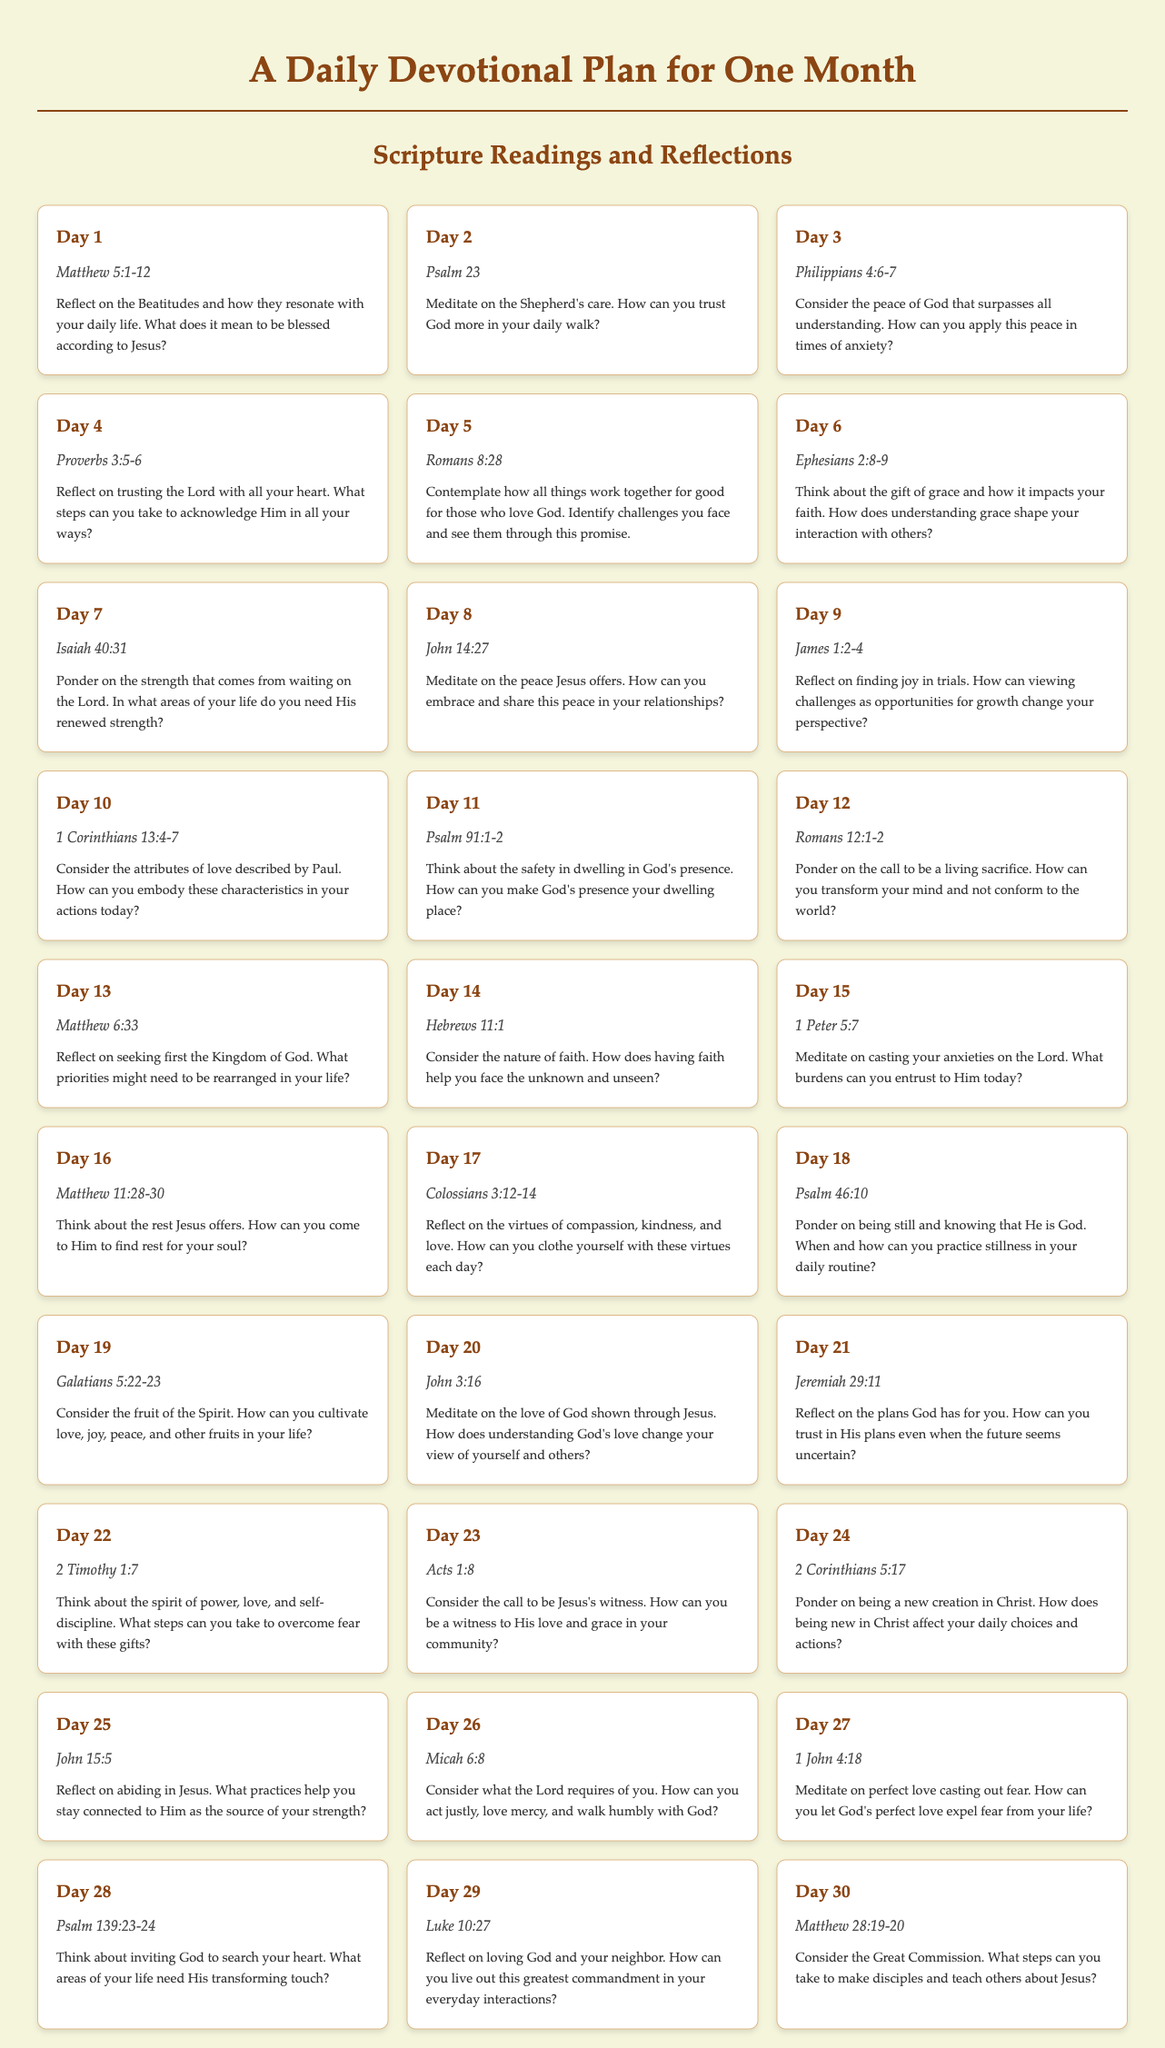What scripture is read on Day 1? Day 1 features a scripture reading from Matthew 5:1-12.
Answer: Matthew 5:1-12 How many days are included in the devotional plan? The document outlines a plan that spans an entire month, consisting of 30 days.
Answer: 30 days What is the reflection theme for Day 3? Day 3 has a reflection on the peace of God that surpasses all understanding.
Answer: The peace of God What scripture focuses on love and your neighbor? The scripture that emphasizes loving God and your neighbor is found in Luke 10:27.
Answer: Luke 10:27 Which day reflects on the Great Commission? The Great Commission is discussed in the reading from Matthew 28:19-20 on the last day.
Answer: Day 30 What are the virtues to clothe oneself with according to Day 17? Day 17 suggests virtues of compassion, kindness, and love to live by.
Answer: Compassion, kindness, and love How does Day 27 address fear? Day 27 emphasizes that perfect love casts out fear, highlighting God's love impact.
Answer: Perfect love casts out fear What is the scripture reading for Day 16? Day 16's scripture is Matthew 11:28-30, which discusses the rest Jesus offers.
Answer: Matthew 11:28-30 